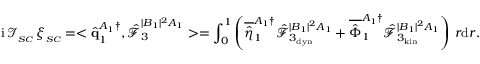<formula> <loc_0><loc_0><loc_500><loc_500>i \, \mathcal { I } _ { _ { S C } } \, \xi _ { _ { S C } } = < \hat { q } _ { 1 } ^ { A _ { 1 } \dagger } , \hat { \mathcal { F } } _ { 3 } ^ { | B _ { 1 } | ^ { 2 } A _ { 1 } } > = \int _ { 0 } ^ { 1 } \left ( \overline { { \hat { \eta } } } _ { 1 } ^ { A _ { 1 } \dagger } \hat { \mathcal { F } } _ { 3 _ { d y n } } ^ { | B _ { 1 } | ^ { 2 } A _ { 1 } } + \overline { { \hat { \Phi } } } _ { 1 } ^ { A _ { 1 } \dagger } \hat { \mathcal { F } } _ { 3 _ { k i n } } ^ { | B _ { 1 } | ^ { 2 } A _ { 1 } } \right ) \, r d r .</formula> 